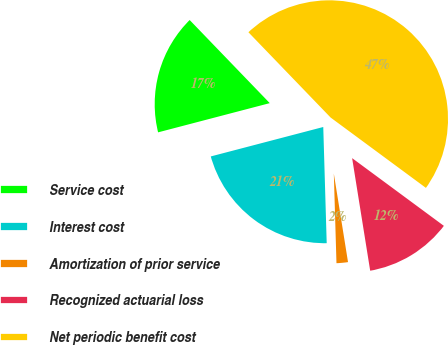Convert chart. <chart><loc_0><loc_0><loc_500><loc_500><pie_chart><fcel>Service cost<fcel>Interest cost<fcel>Amortization of prior service<fcel>Recognized actuarial loss<fcel>Net periodic benefit cost<nl><fcel>16.87%<fcel>21.4%<fcel>2.06%<fcel>12.35%<fcel>47.33%<nl></chart> 